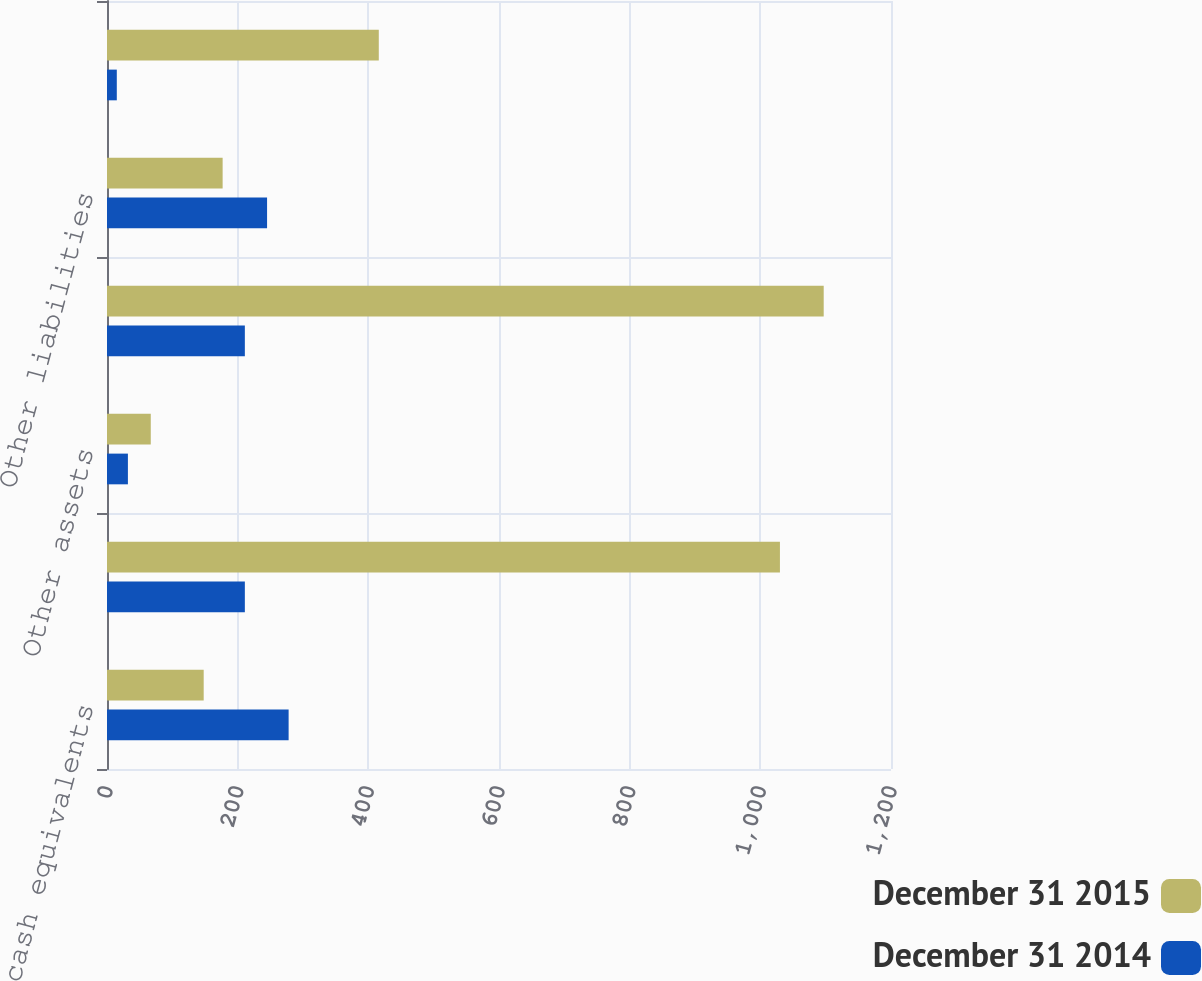Convert chart. <chart><loc_0><loc_0><loc_500><loc_500><stacked_bar_chart><ecel><fcel>Cash and cash equivalents<fcel>Investments<fcel>Other assets<fcel>Total investments and other<fcel>Other liabilities<fcel>Noncontrolling interests of<nl><fcel>December 31 2015<fcel>148<fcel>1030<fcel>67<fcel>1097<fcel>177<fcel>416<nl><fcel>December 31 2014<fcel>278<fcel>211<fcel>32<fcel>211<fcel>245<fcel>15<nl></chart> 